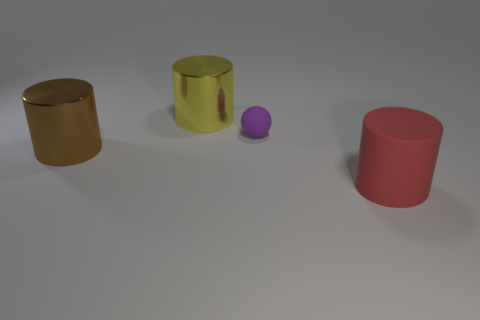Are the purple object and the thing that is behind the small purple rubber thing made of the same material?
Offer a terse response. No. Is there a big brown thing that has the same shape as the large red rubber object?
Offer a terse response. Yes. There is a yellow object that is the same size as the red thing; what is it made of?
Your answer should be very brief. Metal. There is a metal thing behind the tiny purple thing; what size is it?
Your answer should be compact. Large. Do the metal cylinder behind the tiny purple rubber ball and the shiny cylinder to the left of the big yellow metal object have the same size?
Give a very brief answer. Yes. What number of large cylinders have the same material as the purple object?
Your response must be concise. 1. What color is the large matte object?
Ensure brevity in your answer.  Red. Are there any shiny objects in front of the tiny matte thing?
Provide a succinct answer. Yes. Do the tiny object and the big rubber cylinder have the same color?
Your answer should be compact. No. What number of other tiny matte spheres are the same color as the tiny matte ball?
Give a very brief answer. 0. 